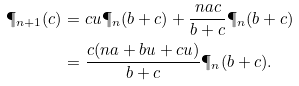<formula> <loc_0><loc_0><loc_500><loc_500>\P _ { n + 1 } ( c ) & = c u \P _ { n } ( b + c ) + \frac { n a c } { b + c } \P _ { n } ( b + c ) \\ & = \frac { c ( n a + b u + c u ) } { b + c } \P _ { n } ( b + c ) .</formula> 